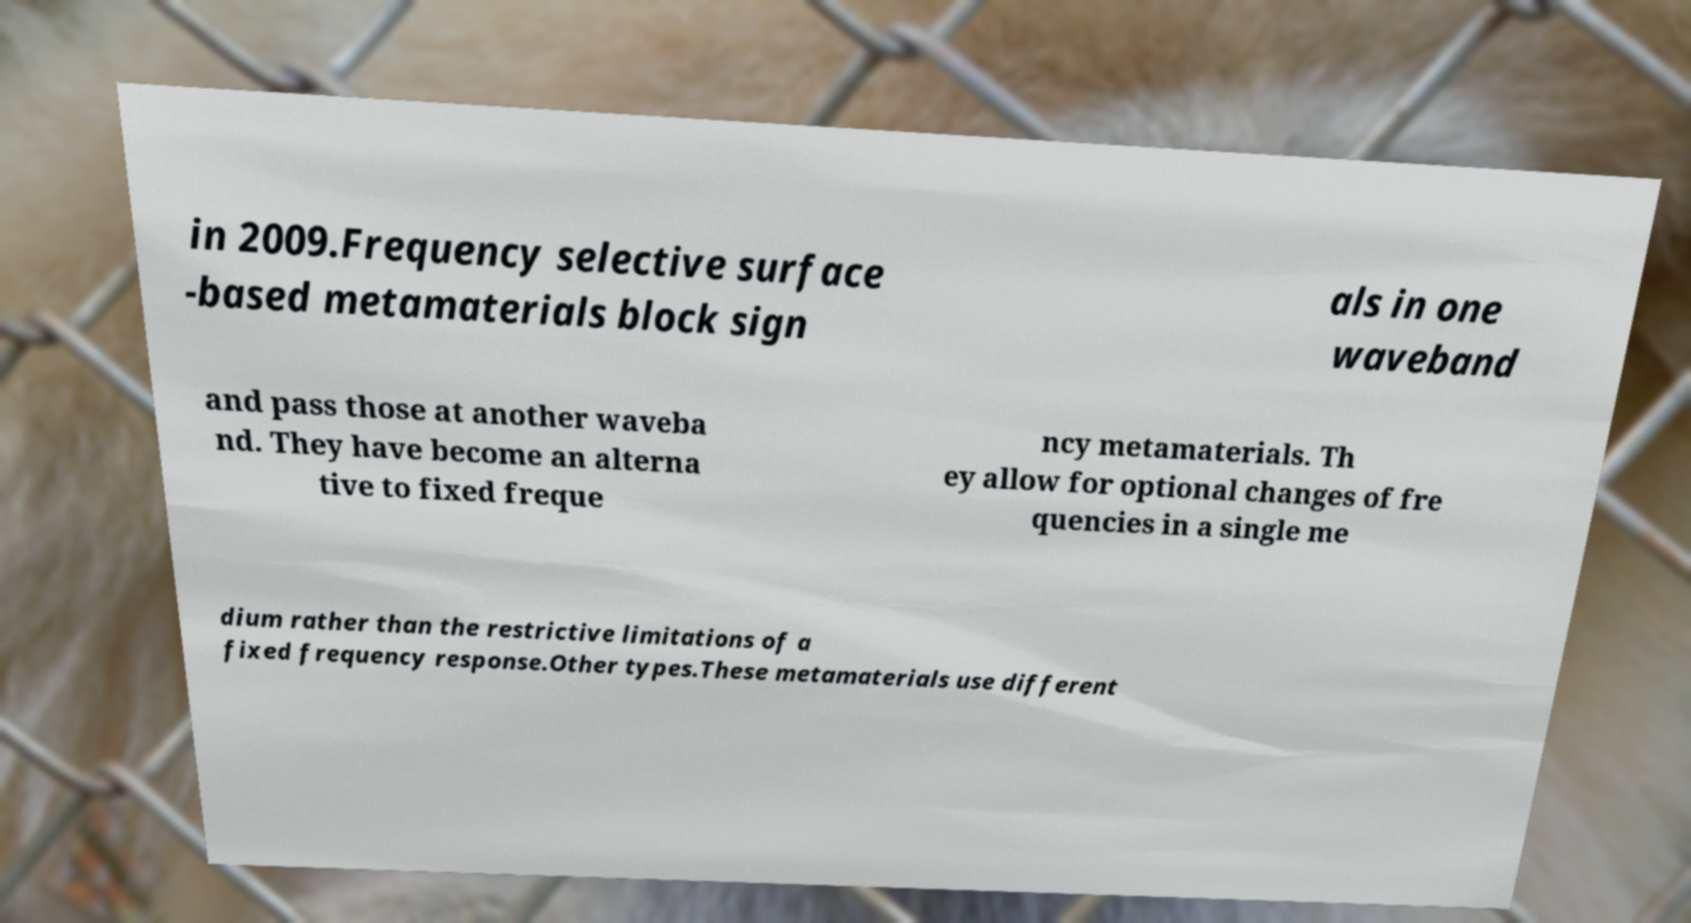What messages or text are displayed in this image? I need them in a readable, typed format. in 2009.Frequency selective surface -based metamaterials block sign als in one waveband and pass those at another waveba nd. They have become an alterna tive to fixed freque ncy metamaterials. Th ey allow for optional changes of fre quencies in a single me dium rather than the restrictive limitations of a fixed frequency response.Other types.These metamaterials use different 